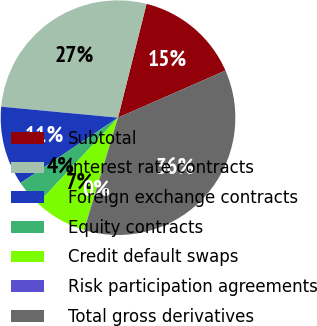Convert chart. <chart><loc_0><loc_0><loc_500><loc_500><pie_chart><fcel>Subtotal<fcel>Interest rate contracts<fcel>Foreign exchange contracts<fcel>Equity contracts<fcel>Credit default swaps<fcel>Risk participation agreements<fcel>Total gross derivatives<nl><fcel>14.51%<fcel>27.42%<fcel>10.89%<fcel>3.65%<fcel>7.27%<fcel>0.03%<fcel>36.24%<nl></chart> 